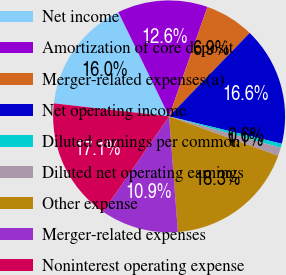<chart> <loc_0><loc_0><loc_500><loc_500><pie_chart><fcel>Net income<fcel>Amortization of core deposit<fcel>Merger-related expenses(a)<fcel>Net operating income<fcel>Diluted earnings per common<fcel>Diluted net operating earnings<fcel>Other expense<fcel>Merger-related expenses<fcel>Noninterest operating expense<nl><fcel>16.0%<fcel>12.57%<fcel>6.86%<fcel>16.57%<fcel>0.57%<fcel>1.14%<fcel>18.29%<fcel>10.86%<fcel>17.14%<nl></chart> 